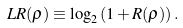<formula> <loc_0><loc_0><loc_500><loc_500>L R ( \rho ) \equiv \log _ { 2 } \left ( 1 + R ( \rho ) \right ) .</formula> 